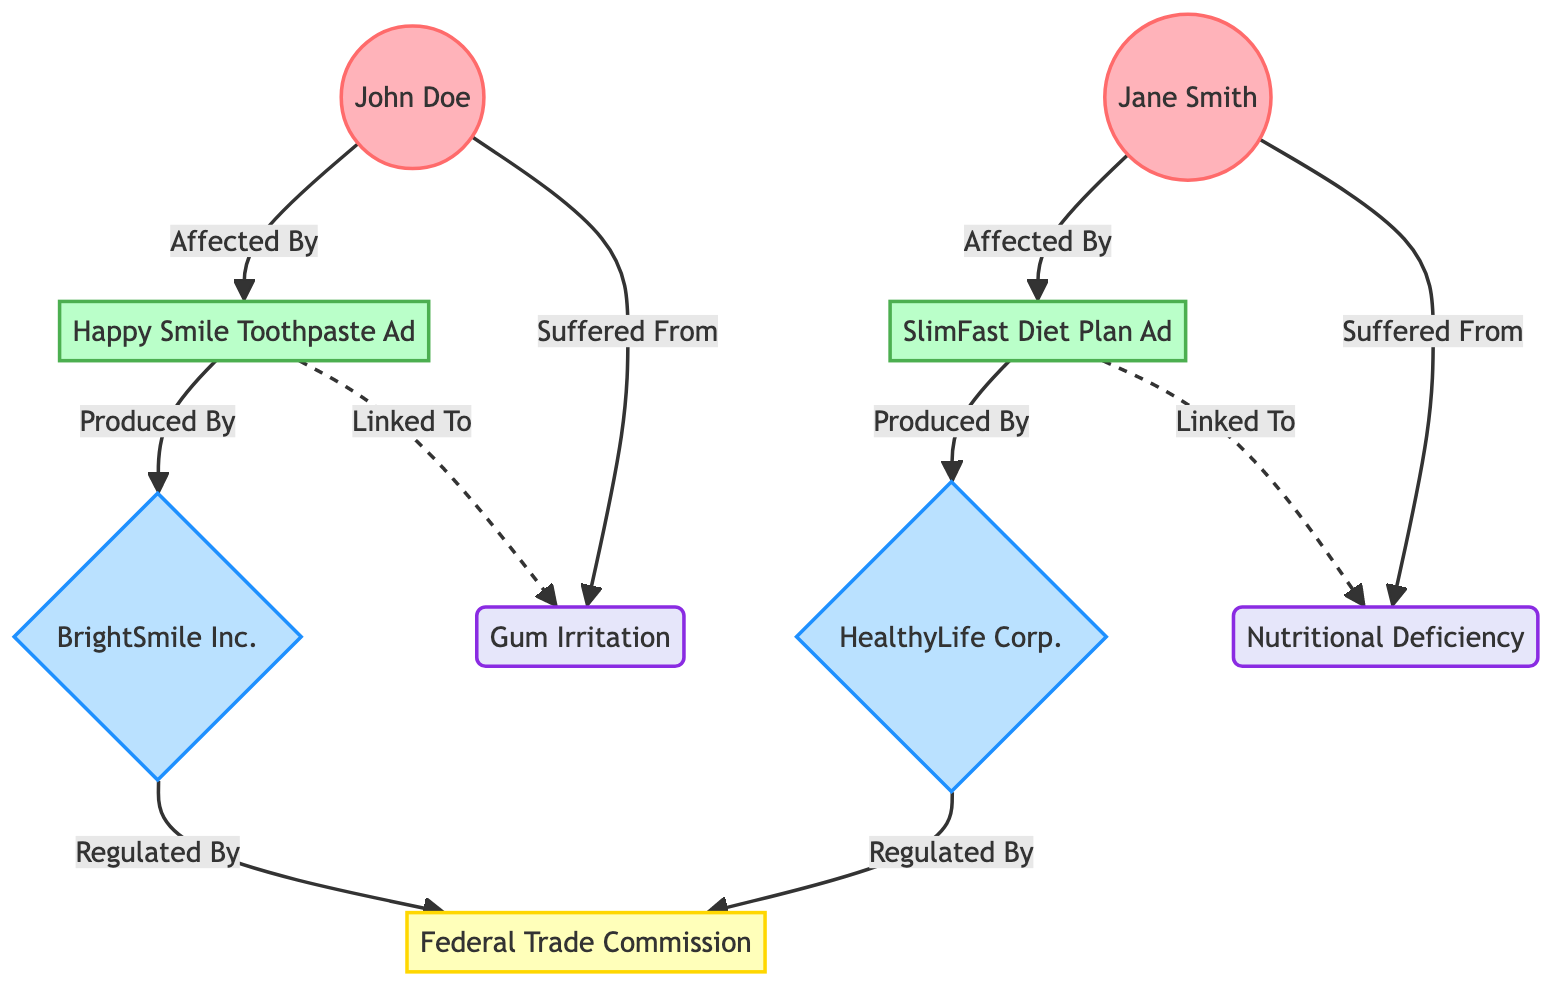What is the impact level of John Doe? The diagram indicates that John Doe's impact level is explicitly mentioned beside his node, which is given as 8.
Answer: 8 Who suffered from Gum Irritation? According to the diagram, there is a connection labeled 'Suffered From' that links John Doe to the health issue of Gum Irritation, indicating that he is the one who suffered from it.
Answer: John Doe Which advertisement is linked to Nutritional Deficiency? The diagram shows that the SlimFast Miraculous Diet Plan Ad is linked to the health issue Nutritional Deficiency with a dashed line labeled 'Linked To', meaning this connection indicates a relationship to that health issue.
Answer: SlimFast Miraculous Diet Plan Ad How many consumers are affected by advertisements? The diagram has two connections where consumers are linked to advertisements: John Doe is connected to Happy Smile Toothpaste Ad, and Jane Smith is connected to SlimFast Miraculous Diet Plan Ad. Therefore, there are two unique connections of consumers affected by advertisements.
Answer: 2 Which company produced the Happy Smile Toothpaste Ad? The link in the diagram clearly states that the Happy Smile Toothpaste Ad is produced by BrightSmile Inc., as indicated by the relationship 'Produced By'.
Answer: BrightSmile Inc Which regulatory agency regulates both companies? Both BrightSmile Inc. and HealthyLife Corp. are connected to the Federal Trade Commission through the relationship 'Regulated By', identifying this agency as the common regulator.
Answer: Federal Trade Commission What health issue is connected to the advertisement produced by HealthyLife Corp.? The diagram shows that the advertisement produced by HealthyLife Corp., which is the SlimFast Miraculous Diet Plan Ad, is linked to the health issue Nutritional Deficiency as indicated by the dashed connection labeled 'Linked To'.
Answer: Nutritional Deficiency What is the severity level of the Happy Smile Toothpaste Ad? The severity of the Happy Smile Toothpaste Ad is described as 'High' in the node's attributes, which indicates the seriousness of its claims or effects.
Answer: High How many total nodes are present in this diagram? By counting each of the distinct nodes listed in the data, including consumers, advertisements, companies, the regulatory agency, and health issues, we can identify a total of 9 different nodes.
Answer: 9 